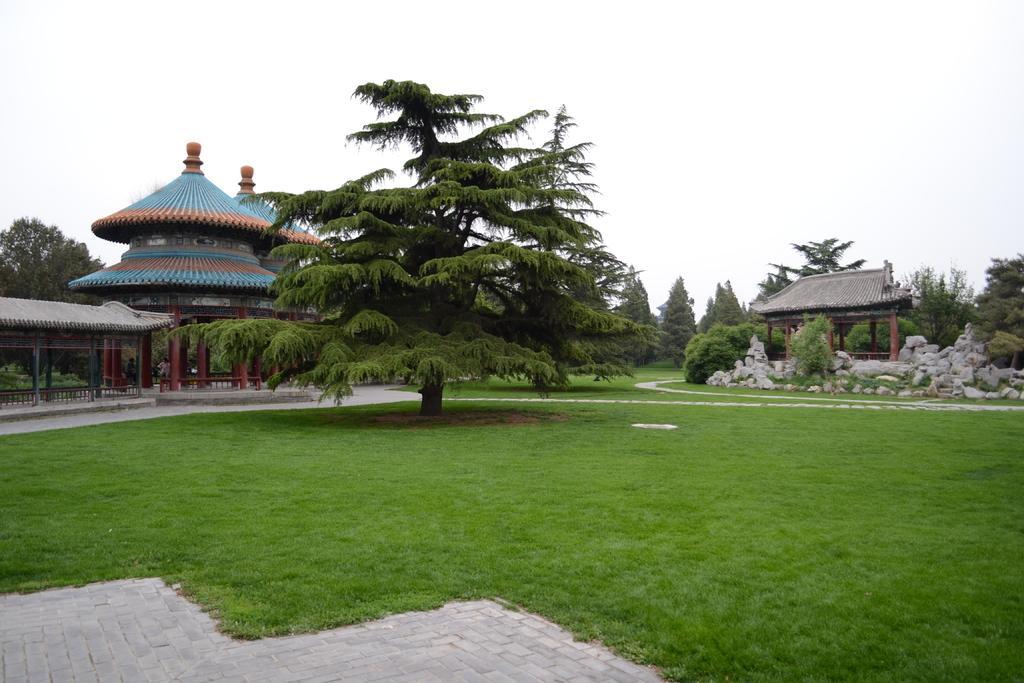Please provide a concise description of this image. In the image there are many trees on the grass land, there is a shed on the right side with a temple on the left side and above its sky. 